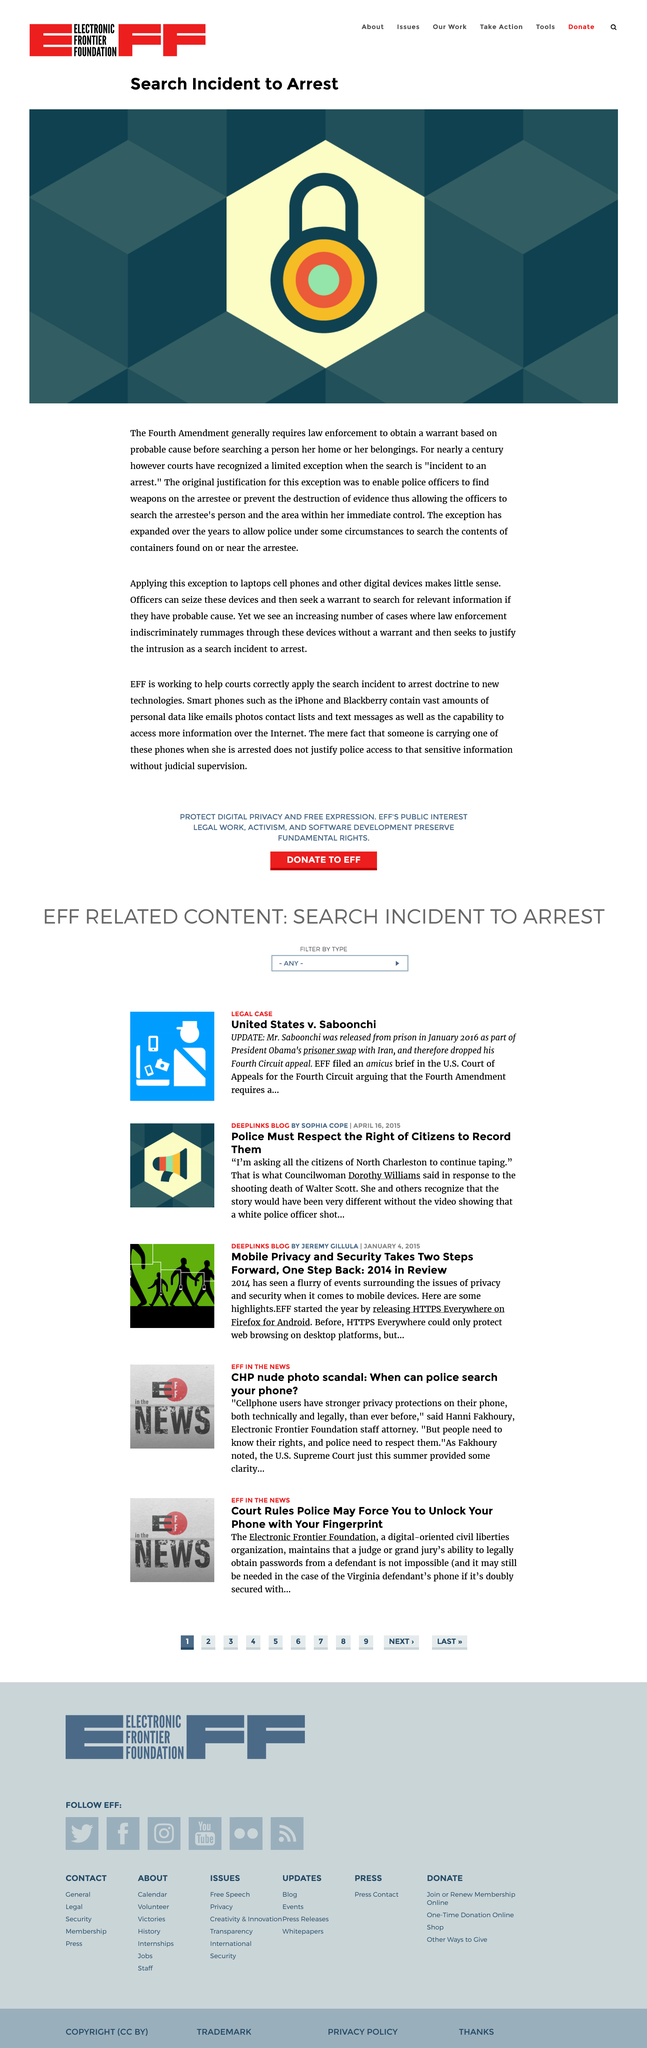Outline some significant characteristics in this image. No, it does not make sense to apply the "incident to an arrest" exception to laptops, cell phones, and other digital devices, as it violates the Fourth Amendment's prohibition on unreasonable searches and seizures. For over a century, courts have recognized a limited exception to the Fourth Amendment. The Fourth Amendment to the United States Constitution requires law enforcement to obtain a warrant based on probable cause before searching a person, unless exceptional circumstances exist. 